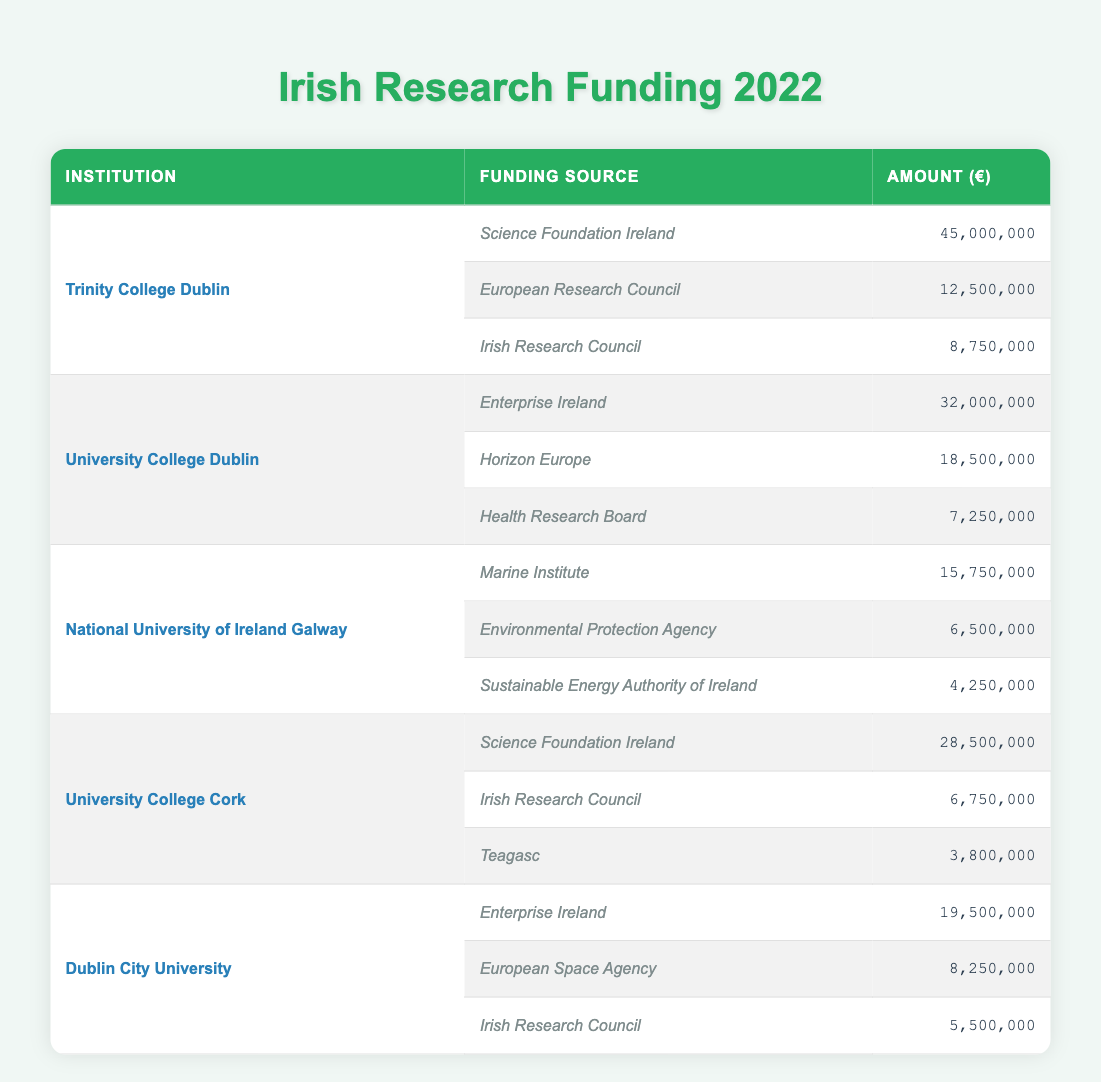What is the total funding received by Trinity College Dublin in 2022? Adding the funding amounts for Trinity College Dublin: 45,000,000 (Science Foundation Ireland) + 12,500,000 (European Research Council) + 8,750,000 (Irish Research Council) equals 66,250,000.
Answer: 66,250,000 Which institution received the highest amount of funding from Science Foundation Ireland? The institutions that received funding from Science Foundation Ireland are Trinity College Dublin (45,000,000) and University College Cork (28,500,000). Since 45,000,000 is greater than 28,500,000, Trinity College Dublin received the highest amount.
Answer: Trinity College Dublin Did Dublin City University receive more funding than National University of Ireland Galway? Dublin City University received a total of 19,500,000 (Enterprise Ireland) + 8,250,000 (European Space Agency) + 5,500,000 (Irish Research Council) totaling 33,250,000. National University of Ireland Galway received 15,750,000 (Marine Institute) + 6,500,000 (Environmental Protection Agency) + 4,250,000 (Sustainable Energy Authority of Ireland) totaling 26,500,000. Since 33,250,000 is greater than 26,500,000, the answer is yes.
Answer: Yes What is the average funding amount received by University College Cork from all sources? University College Cork received 28,500,000 (Science Foundation Ireland) + 6,750,000 (Irish Research Council) + 3,800,000 (Teagasc) totaling 39,050,000. This amount is divided by 3 (the number of sources) which results in 13,016,666.67.
Answer: 13,016,666.67 Is it true that health research funding from the Health Research Board to University College Dublin is greater than the funding from the Marine Institute to National University of Ireland Galway? University College Dublin received 7,250,000 from the Health Research Board. National University of Ireland Galway received 15,750,000 from the Marine Institute. Since 7,250,000 is less than 15,750,000, the answer is false.
Answer: False What is the total amount of funding for University College Cork from the Irish Research Council? University College Cork received 6,750,000 from the Irish Research Council, which is the only funding listed from that source.
Answer: 6,750,000 What was the total amount of funding received by all institutions from Enterprise Ireland? Counting the amounts: University College Dublin received 32,000,000 and Dublin City University received 19,500,000. Adding these yields: 32,000,000 + 19,500,000 equals 51,500,000.
Answer: 51,500,000 Which funding source contributed the least amount to any institution? The smallest amount shown in the table is from Teagasc, which contributed 3,800,000 to University College Cork.
Answer: Teagasc with 3,800,000 How many different funding sources were listed for the National University of Ireland Galway? The National University of Ireland Galway received funding from three different sources: Marine Institute, Environmental Protection Agency, and Sustainable Energy Authority of Ireland. Therefore, the count is three.
Answer: 3 